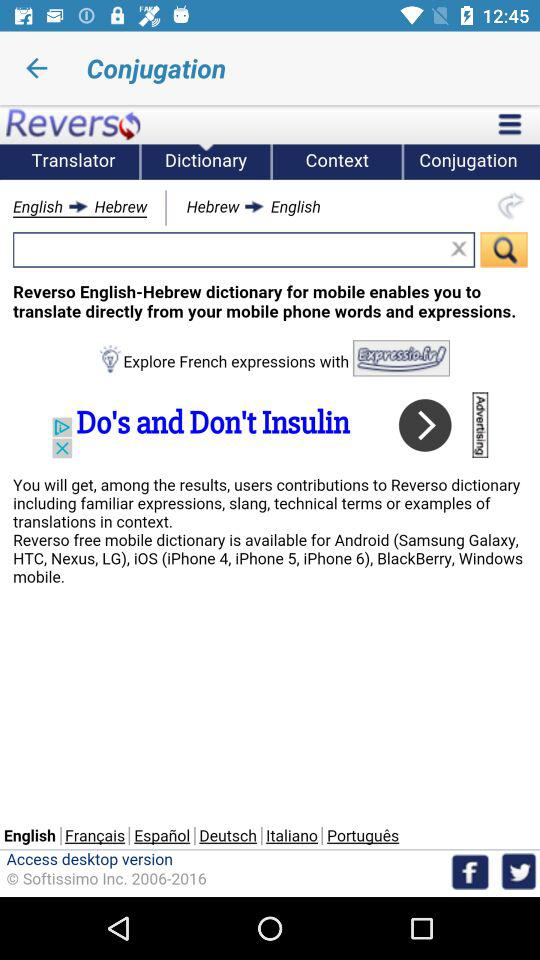Which language is currently selected for translation other than English? The currently selected language for translation other than English is Hebrew. 